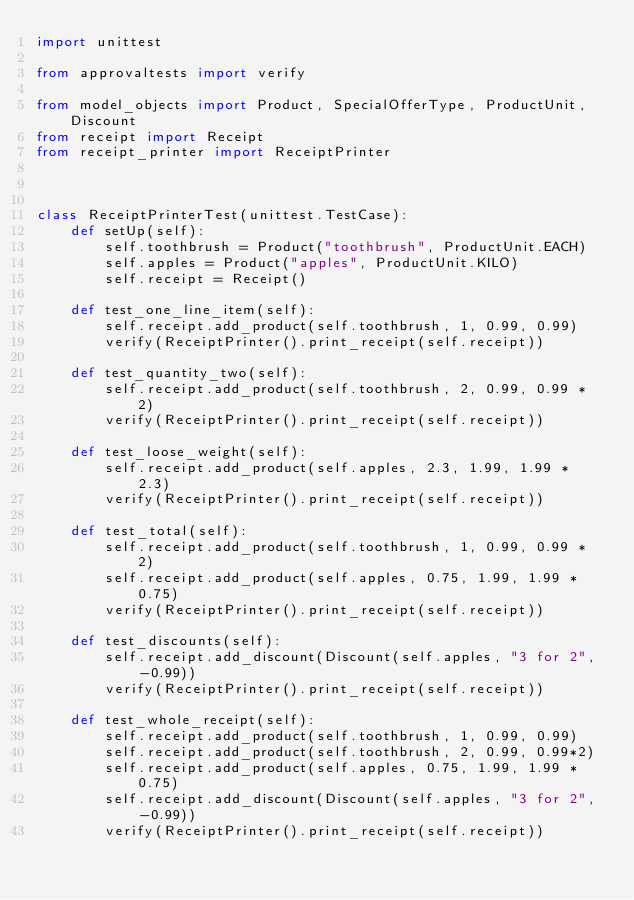Convert code to text. <code><loc_0><loc_0><loc_500><loc_500><_Python_>import unittest

from approvaltests import verify

from model_objects import Product, SpecialOfferType, ProductUnit, Discount
from receipt import Receipt
from receipt_printer import ReceiptPrinter



class ReceiptPrinterTest(unittest.TestCase):
    def setUp(self):
        self.toothbrush = Product("toothbrush", ProductUnit.EACH)
        self.apples = Product("apples", ProductUnit.KILO)
        self.receipt = Receipt()

    def test_one_line_item(self):
        self.receipt.add_product(self.toothbrush, 1, 0.99, 0.99)
        verify(ReceiptPrinter().print_receipt(self.receipt))

    def test_quantity_two(self):
        self.receipt.add_product(self.toothbrush, 2, 0.99, 0.99 * 2)
        verify(ReceiptPrinter().print_receipt(self.receipt))

    def test_loose_weight(self):
        self.receipt.add_product(self.apples, 2.3, 1.99, 1.99 * 2.3)
        verify(ReceiptPrinter().print_receipt(self.receipt))

    def test_total(self):
        self.receipt.add_product(self.toothbrush, 1, 0.99, 0.99 * 2)
        self.receipt.add_product(self.apples, 0.75, 1.99, 1.99 * 0.75)
        verify(ReceiptPrinter().print_receipt(self.receipt))

    def test_discounts(self):
        self.receipt.add_discount(Discount(self.apples, "3 for 2", -0.99))
        verify(ReceiptPrinter().print_receipt(self.receipt))

    def test_whole_receipt(self):
        self.receipt.add_product(self.toothbrush, 1, 0.99, 0.99)
        self.receipt.add_product(self.toothbrush, 2, 0.99, 0.99*2)
        self.receipt.add_product(self.apples, 0.75, 1.99, 1.99 * 0.75)
        self.receipt.add_discount(Discount(self.apples, "3 for 2", -0.99))
        verify(ReceiptPrinter().print_receipt(self.receipt))
</code> 